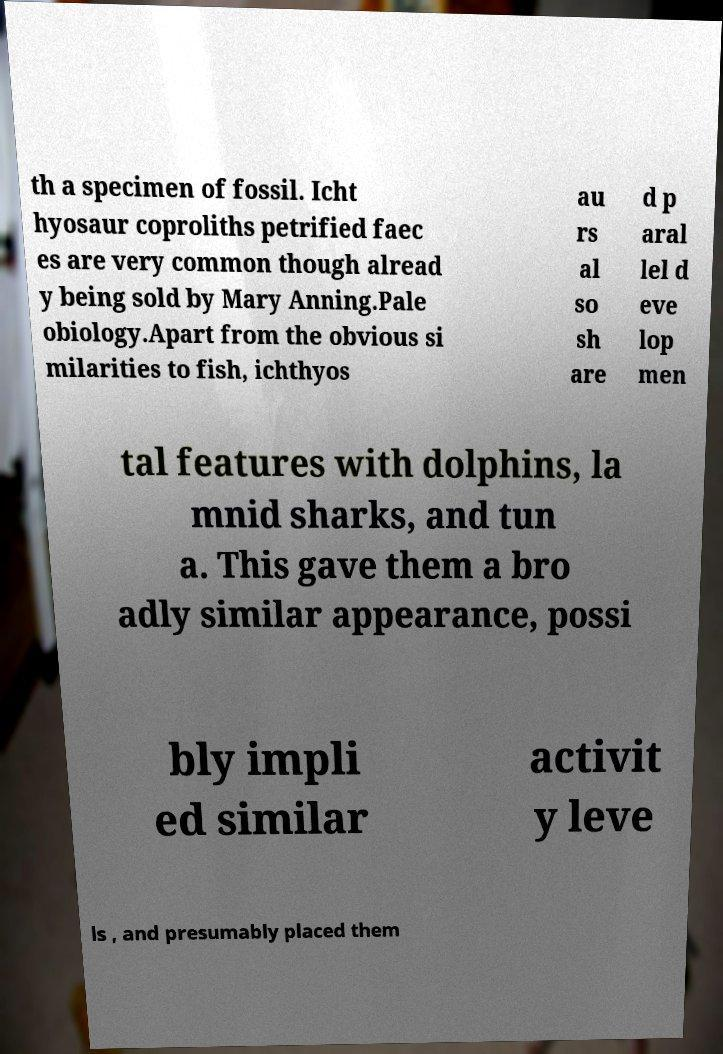Please identify and transcribe the text found in this image. th a specimen of fossil. Icht hyosaur coproliths petrified faec es are very common though alread y being sold by Mary Anning.Pale obiology.Apart from the obvious si milarities to fish, ichthyos au rs al so sh are d p aral lel d eve lop men tal features with dolphins, la mnid sharks, and tun a. This gave them a bro adly similar appearance, possi bly impli ed similar activit y leve ls , and presumably placed them 